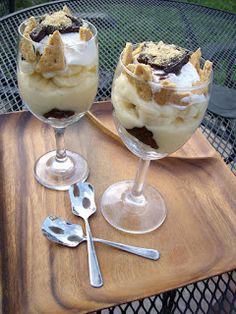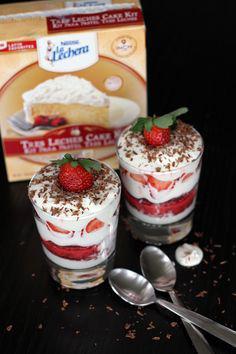The first image is the image on the left, the second image is the image on the right. Evaluate the accuracy of this statement regarding the images: "In one image, a large creamy dessert is displayed in a clear footed bowl, while a second image shows at least one individual dessert with the same number of spoons.". Is it true? Answer yes or no. No. The first image is the image on the left, the second image is the image on the right. Given the left and right images, does the statement "An image shows a creamy layered dessert with one row of brown shapes arranged inside the glass of the footed serving bowl." hold true? Answer yes or no. No. 